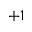<formula> <loc_0><loc_0><loc_500><loc_500>+ 1</formula> 